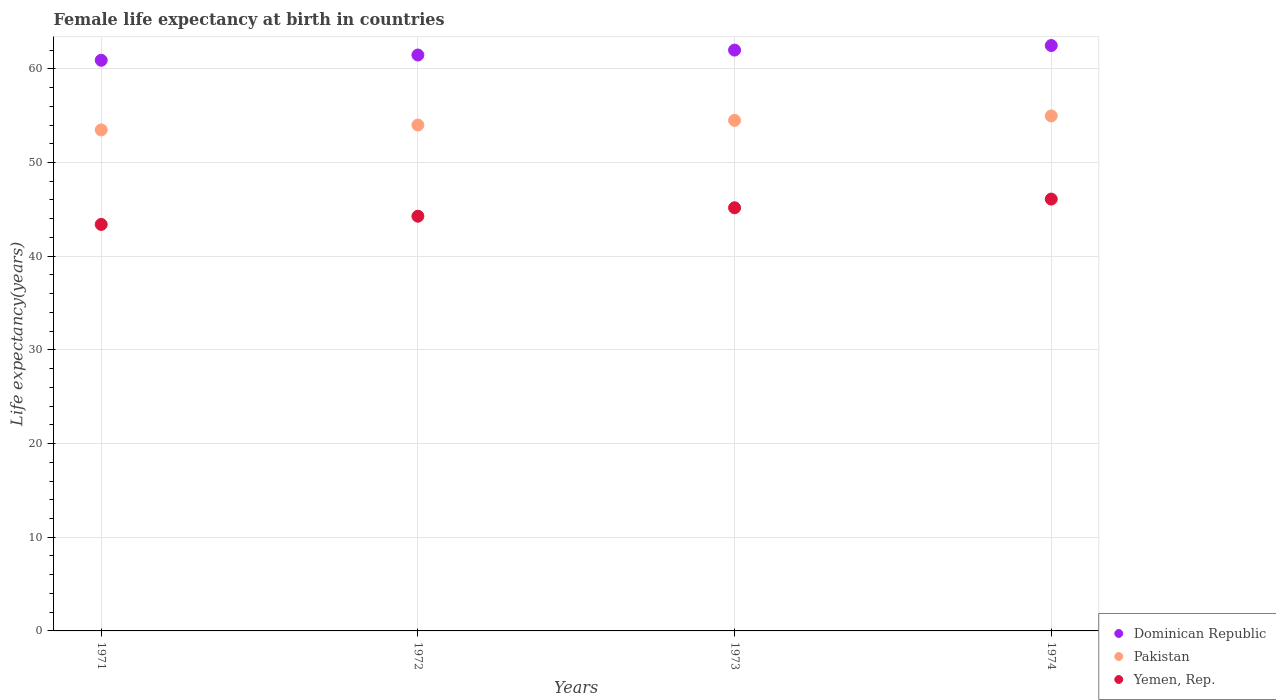How many different coloured dotlines are there?
Your answer should be compact. 3. What is the female life expectancy at birth in Yemen, Rep. in 1972?
Your answer should be compact. 44.27. Across all years, what is the maximum female life expectancy at birth in Yemen, Rep.?
Give a very brief answer. 46.1. Across all years, what is the minimum female life expectancy at birth in Dominican Republic?
Your response must be concise. 60.91. In which year was the female life expectancy at birth in Dominican Republic maximum?
Offer a very short reply. 1974. In which year was the female life expectancy at birth in Dominican Republic minimum?
Give a very brief answer. 1971. What is the total female life expectancy at birth in Pakistan in the graph?
Give a very brief answer. 216.96. What is the difference between the female life expectancy at birth in Pakistan in 1973 and that in 1974?
Make the answer very short. -0.48. What is the difference between the female life expectancy at birth in Dominican Republic in 1972 and the female life expectancy at birth in Pakistan in 1974?
Provide a short and direct response. 6.5. What is the average female life expectancy at birth in Dominican Republic per year?
Provide a short and direct response. 61.72. In the year 1972, what is the difference between the female life expectancy at birth in Pakistan and female life expectancy at birth in Dominican Republic?
Make the answer very short. -7.47. What is the ratio of the female life expectancy at birth in Pakistan in 1971 to that in 1974?
Your answer should be compact. 0.97. What is the difference between the highest and the second highest female life expectancy at birth in Dominican Republic?
Your answer should be very brief. 0.49. What is the difference between the highest and the lowest female life expectancy at birth in Yemen, Rep.?
Your answer should be compact. 2.71. Is the sum of the female life expectancy at birth in Dominican Republic in 1972 and 1974 greater than the maximum female life expectancy at birth in Pakistan across all years?
Offer a terse response. Yes. How many dotlines are there?
Your response must be concise. 3. What is the difference between two consecutive major ticks on the Y-axis?
Provide a short and direct response. 10. What is the title of the graph?
Your answer should be compact. Female life expectancy at birth in countries. Does "Equatorial Guinea" appear as one of the legend labels in the graph?
Your response must be concise. No. What is the label or title of the Y-axis?
Your answer should be very brief. Life expectancy(years). What is the Life expectancy(years) of Dominican Republic in 1971?
Your response must be concise. 60.91. What is the Life expectancy(years) in Pakistan in 1971?
Keep it short and to the point. 53.48. What is the Life expectancy(years) in Yemen, Rep. in 1971?
Offer a terse response. 43.39. What is the Life expectancy(years) of Dominican Republic in 1972?
Provide a succinct answer. 61.48. What is the Life expectancy(years) of Pakistan in 1972?
Your response must be concise. 54. What is the Life expectancy(years) of Yemen, Rep. in 1972?
Offer a very short reply. 44.27. What is the Life expectancy(years) of Dominican Republic in 1973?
Your answer should be compact. 62. What is the Life expectancy(years) in Pakistan in 1973?
Keep it short and to the point. 54.5. What is the Life expectancy(years) of Yemen, Rep. in 1973?
Provide a succinct answer. 45.17. What is the Life expectancy(years) of Dominican Republic in 1974?
Offer a very short reply. 62.49. What is the Life expectancy(years) of Pakistan in 1974?
Ensure brevity in your answer.  54.98. What is the Life expectancy(years) of Yemen, Rep. in 1974?
Your answer should be compact. 46.1. Across all years, what is the maximum Life expectancy(years) in Dominican Republic?
Give a very brief answer. 62.49. Across all years, what is the maximum Life expectancy(years) in Pakistan?
Ensure brevity in your answer.  54.98. Across all years, what is the maximum Life expectancy(years) in Yemen, Rep.?
Offer a very short reply. 46.1. Across all years, what is the minimum Life expectancy(years) of Dominican Republic?
Ensure brevity in your answer.  60.91. Across all years, what is the minimum Life expectancy(years) in Pakistan?
Your response must be concise. 53.48. Across all years, what is the minimum Life expectancy(years) of Yemen, Rep.?
Provide a short and direct response. 43.39. What is the total Life expectancy(years) of Dominican Republic in the graph?
Give a very brief answer. 246.88. What is the total Life expectancy(years) of Pakistan in the graph?
Give a very brief answer. 216.96. What is the total Life expectancy(years) of Yemen, Rep. in the graph?
Make the answer very short. 178.93. What is the difference between the Life expectancy(years) of Dominican Republic in 1971 and that in 1972?
Make the answer very short. -0.56. What is the difference between the Life expectancy(years) of Pakistan in 1971 and that in 1972?
Provide a short and direct response. -0.52. What is the difference between the Life expectancy(years) in Yemen, Rep. in 1971 and that in 1972?
Offer a very short reply. -0.88. What is the difference between the Life expectancy(years) of Dominican Republic in 1971 and that in 1973?
Offer a very short reply. -1.09. What is the difference between the Life expectancy(years) in Pakistan in 1971 and that in 1973?
Provide a short and direct response. -1.02. What is the difference between the Life expectancy(years) in Yemen, Rep. in 1971 and that in 1973?
Your answer should be compact. -1.78. What is the difference between the Life expectancy(years) of Dominican Republic in 1971 and that in 1974?
Provide a short and direct response. -1.57. What is the difference between the Life expectancy(years) of Pakistan in 1971 and that in 1974?
Offer a terse response. -1.49. What is the difference between the Life expectancy(years) of Yemen, Rep. in 1971 and that in 1974?
Keep it short and to the point. -2.71. What is the difference between the Life expectancy(years) of Dominican Republic in 1972 and that in 1973?
Your answer should be very brief. -0.53. What is the difference between the Life expectancy(years) of Pakistan in 1972 and that in 1973?
Offer a terse response. -0.5. What is the difference between the Life expectancy(years) of Yemen, Rep. in 1972 and that in 1973?
Make the answer very short. -0.9. What is the difference between the Life expectancy(years) in Dominican Republic in 1972 and that in 1974?
Your answer should be very brief. -1.01. What is the difference between the Life expectancy(years) of Pakistan in 1972 and that in 1974?
Ensure brevity in your answer.  -0.97. What is the difference between the Life expectancy(years) of Yemen, Rep. in 1972 and that in 1974?
Offer a terse response. -1.83. What is the difference between the Life expectancy(years) in Dominican Republic in 1973 and that in 1974?
Your answer should be very brief. -0.49. What is the difference between the Life expectancy(years) of Pakistan in 1973 and that in 1974?
Your answer should be very brief. -0.48. What is the difference between the Life expectancy(years) in Yemen, Rep. in 1973 and that in 1974?
Offer a very short reply. -0.93. What is the difference between the Life expectancy(years) of Dominican Republic in 1971 and the Life expectancy(years) of Pakistan in 1972?
Offer a very short reply. 6.91. What is the difference between the Life expectancy(years) in Dominican Republic in 1971 and the Life expectancy(years) in Yemen, Rep. in 1972?
Offer a very short reply. 16.65. What is the difference between the Life expectancy(years) of Pakistan in 1971 and the Life expectancy(years) of Yemen, Rep. in 1972?
Your response must be concise. 9.21. What is the difference between the Life expectancy(years) in Dominican Republic in 1971 and the Life expectancy(years) in Pakistan in 1973?
Your response must be concise. 6.42. What is the difference between the Life expectancy(years) of Dominican Republic in 1971 and the Life expectancy(years) of Yemen, Rep. in 1973?
Your answer should be very brief. 15.74. What is the difference between the Life expectancy(years) of Pakistan in 1971 and the Life expectancy(years) of Yemen, Rep. in 1973?
Offer a very short reply. 8.31. What is the difference between the Life expectancy(years) in Dominican Republic in 1971 and the Life expectancy(years) in Pakistan in 1974?
Your answer should be compact. 5.94. What is the difference between the Life expectancy(years) of Dominican Republic in 1971 and the Life expectancy(years) of Yemen, Rep. in 1974?
Ensure brevity in your answer.  14.82. What is the difference between the Life expectancy(years) in Pakistan in 1971 and the Life expectancy(years) in Yemen, Rep. in 1974?
Offer a very short reply. 7.38. What is the difference between the Life expectancy(years) of Dominican Republic in 1972 and the Life expectancy(years) of Pakistan in 1973?
Offer a very short reply. 6.98. What is the difference between the Life expectancy(years) of Dominican Republic in 1972 and the Life expectancy(years) of Yemen, Rep. in 1973?
Your answer should be compact. 16.31. What is the difference between the Life expectancy(years) of Pakistan in 1972 and the Life expectancy(years) of Yemen, Rep. in 1973?
Your answer should be compact. 8.83. What is the difference between the Life expectancy(years) of Dominican Republic in 1972 and the Life expectancy(years) of Pakistan in 1974?
Give a very brief answer. 6.5. What is the difference between the Life expectancy(years) of Dominican Republic in 1972 and the Life expectancy(years) of Yemen, Rep. in 1974?
Offer a very short reply. 15.38. What is the difference between the Life expectancy(years) in Pakistan in 1972 and the Life expectancy(years) in Yemen, Rep. in 1974?
Ensure brevity in your answer.  7.91. What is the difference between the Life expectancy(years) in Dominican Republic in 1973 and the Life expectancy(years) in Pakistan in 1974?
Your answer should be compact. 7.03. What is the difference between the Life expectancy(years) in Dominican Republic in 1973 and the Life expectancy(years) in Yemen, Rep. in 1974?
Provide a succinct answer. 15.9. What is the difference between the Life expectancy(years) of Pakistan in 1973 and the Life expectancy(years) of Yemen, Rep. in 1974?
Your answer should be compact. 8.4. What is the average Life expectancy(years) of Dominican Republic per year?
Provide a short and direct response. 61.72. What is the average Life expectancy(years) in Pakistan per year?
Provide a succinct answer. 54.24. What is the average Life expectancy(years) of Yemen, Rep. per year?
Make the answer very short. 44.73. In the year 1971, what is the difference between the Life expectancy(years) of Dominican Republic and Life expectancy(years) of Pakistan?
Your answer should be compact. 7.43. In the year 1971, what is the difference between the Life expectancy(years) in Dominican Republic and Life expectancy(years) in Yemen, Rep.?
Offer a very short reply. 17.52. In the year 1971, what is the difference between the Life expectancy(years) in Pakistan and Life expectancy(years) in Yemen, Rep.?
Make the answer very short. 10.09. In the year 1972, what is the difference between the Life expectancy(years) of Dominican Republic and Life expectancy(years) of Pakistan?
Your answer should be compact. 7.47. In the year 1972, what is the difference between the Life expectancy(years) of Dominican Republic and Life expectancy(years) of Yemen, Rep.?
Offer a very short reply. 17.21. In the year 1972, what is the difference between the Life expectancy(years) in Pakistan and Life expectancy(years) in Yemen, Rep.?
Offer a very short reply. 9.73. In the year 1973, what is the difference between the Life expectancy(years) in Dominican Republic and Life expectancy(years) in Pakistan?
Keep it short and to the point. 7.5. In the year 1973, what is the difference between the Life expectancy(years) of Dominican Republic and Life expectancy(years) of Yemen, Rep.?
Your answer should be very brief. 16.83. In the year 1973, what is the difference between the Life expectancy(years) of Pakistan and Life expectancy(years) of Yemen, Rep.?
Provide a short and direct response. 9.33. In the year 1974, what is the difference between the Life expectancy(years) in Dominican Republic and Life expectancy(years) in Pakistan?
Give a very brief answer. 7.51. In the year 1974, what is the difference between the Life expectancy(years) of Dominican Republic and Life expectancy(years) of Yemen, Rep.?
Offer a very short reply. 16.39. In the year 1974, what is the difference between the Life expectancy(years) of Pakistan and Life expectancy(years) of Yemen, Rep.?
Ensure brevity in your answer.  8.88. What is the ratio of the Life expectancy(years) in Dominican Republic in 1971 to that in 1972?
Ensure brevity in your answer.  0.99. What is the ratio of the Life expectancy(years) of Yemen, Rep. in 1971 to that in 1972?
Your answer should be very brief. 0.98. What is the ratio of the Life expectancy(years) of Dominican Republic in 1971 to that in 1973?
Ensure brevity in your answer.  0.98. What is the ratio of the Life expectancy(years) of Pakistan in 1971 to that in 1973?
Ensure brevity in your answer.  0.98. What is the ratio of the Life expectancy(years) in Yemen, Rep. in 1971 to that in 1973?
Provide a succinct answer. 0.96. What is the ratio of the Life expectancy(years) in Dominican Republic in 1971 to that in 1974?
Your answer should be compact. 0.97. What is the ratio of the Life expectancy(years) in Pakistan in 1971 to that in 1974?
Ensure brevity in your answer.  0.97. What is the ratio of the Life expectancy(years) of Yemen, Rep. in 1971 to that in 1974?
Your answer should be compact. 0.94. What is the ratio of the Life expectancy(years) in Dominican Republic in 1972 to that in 1973?
Offer a terse response. 0.99. What is the ratio of the Life expectancy(years) of Pakistan in 1972 to that in 1973?
Your response must be concise. 0.99. What is the ratio of the Life expectancy(years) in Yemen, Rep. in 1972 to that in 1973?
Ensure brevity in your answer.  0.98. What is the ratio of the Life expectancy(years) of Dominican Republic in 1972 to that in 1974?
Offer a terse response. 0.98. What is the ratio of the Life expectancy(years) in Pakistan in 1972 to that in 1974?
Provide a short and direct response. 0.98. What is the ratio of the Life expectancy(years) of Yemen, Rep. in 1972 to that in 1974?
Provide a succinct answer. 0.96. What is the ratio of the Life expectancy(years) in Pakistan in 1973 to that in 1974?
Your answer should be compact. 0.99. What is the ratio of the Life expectancy(years) in Yemen, Rep. in 1973 to that in 1974?
Your response must be concise. 0.98. What is the difference between the highest and the second highest Life expectancy(years) in Dominican Republic?
Your response must be concise. 0.49. What is the difference between the highest and the second highest Life expectancy(years) of Pakistan?
Provide a short and direct response. 0.48. What is the difference between the highest and the second highest Life expectancy(years) in Yemen, Rep.?
Your response must be concise. 0.93. What is the difference between the highest and the lowest Life expectancy(years) in Dominican Republic?
Your answer should be very brief. 1.57. What is the difference between the highest and the lowest Life expectancy(years) of Pakistan?
Give a very brief answer. 1.49. What is the difference between the highest and the lowest Life expectancy(years) of Yemen, Rep.?
Give a very brief answer. 2.71. 